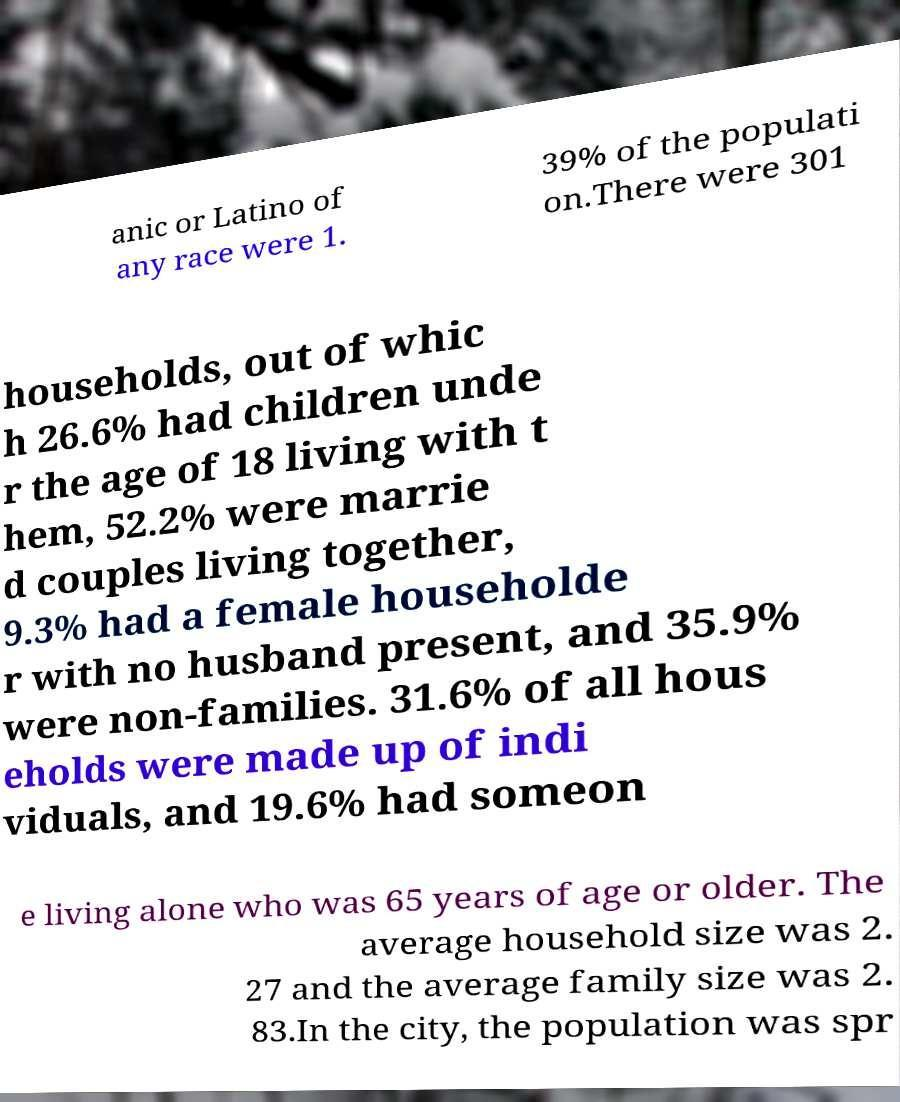Could you extract and type out the text from this image? anic or Latino of any race were 1. 39% of the populati on.There were 301 households, out of whic h 26.6% had children unde r the age of 18 living with t hem, 52.2% were marrie d couples living together, 9.3% had a female householde r with no husband present, and 35.9% were non-families. 31.6% of all hous eholds were made up of indi viduals, and 19.6% had someon e living alone who was 65 years of age or older. The average household size was 2. 27 and the average family size was 2. 83.In the city, the population was spr 